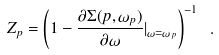<formula> <loc_0><loc_0><loc_500><loc_500>Z _ { p } = \left ( 1 - \frac { \partial \Sigma ( p , \omega _ { p } ) } { \partial \omega } | _ { \omega = \omega _ { p } } \right ) ^ { - 1 } \ .</formula> 